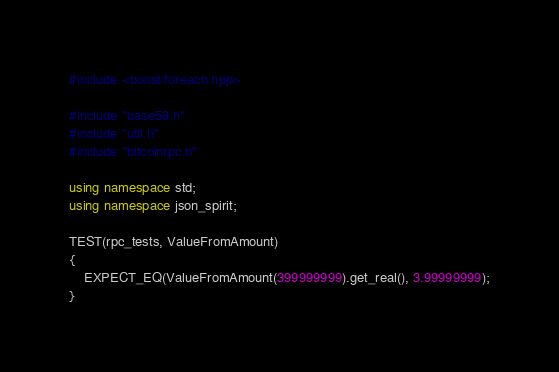<code> <loc_0><loc_0><loc_500><loc_500><_C++_>#include <boost/foreach.hpp>

#include "base58.h"
#include "util.h"
#include "bitcoinrpc.h"

using namespace std;
using namespace json_spirit;

TEST(rpc_tests, ValueFromAmount)
{
    EXPECT_EQ(ValueFromAmount(399999999).get_real(), 3.99999999);
}
</code> 